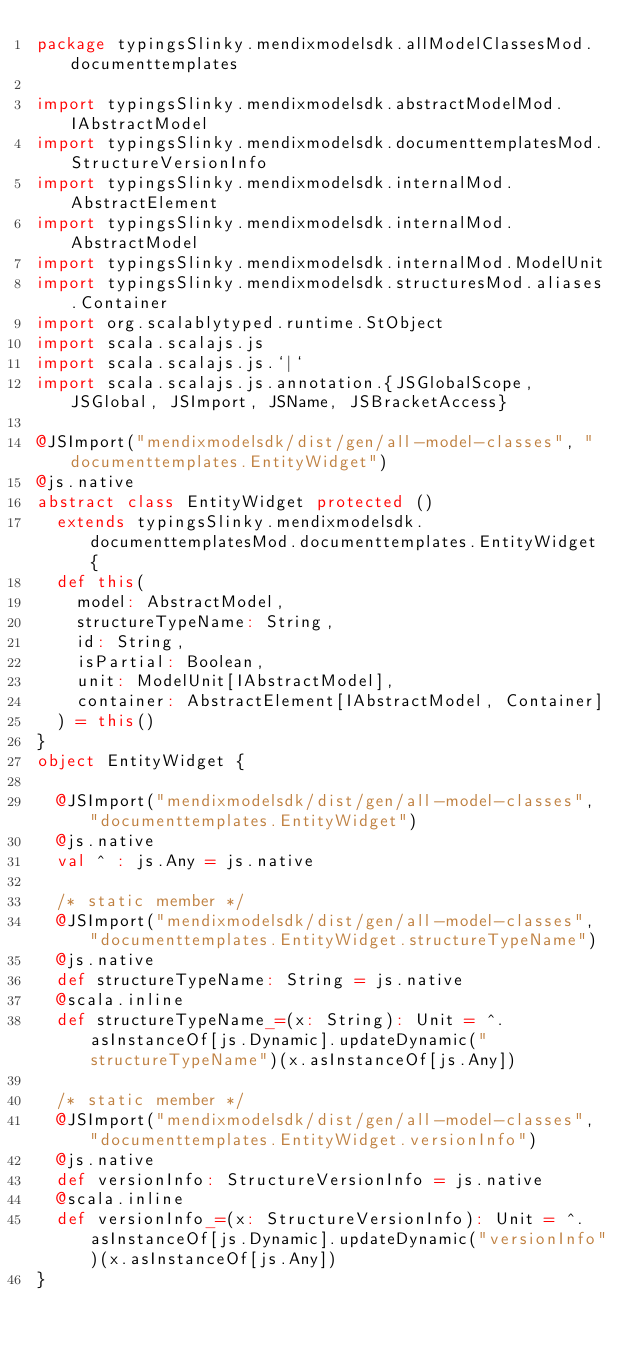Convert code to text. <code><loc_0><loc_0><loc_500><loc_500><_Scala_>package typingsSlinky.mendixmodelsdk.allModelClassesMod.documenttemplates

import typingsSlinky.mendixmodelsdk.abstractModelMod.IAbstractModel
import typingsSlinky.mendixmodelsdk.documenttemplatesMod.StructureVersionInfo
import typingsSlinky.mendixmodelsdk.internalMod.AbstractElement
import typingsSlinky.mendixmodelsdk.internalMod.AbstractModel
import typingsSlinky.mendixmodelsdk.internalMod.ModelUnit
import typingsSlinky.mendixmodelsdk.structuresMod.aliases.Container
import org.scalablytyped.runtime.StObject
import scala.scalajs.js
import scala.scalajs.js.`|`
import scala.scalajs.js.annotation.{JSGlobalScope, JSGlobal, JSImport, JSName, JSBracketAccess}

@JSImport("mendixmodelsdk/dist/gen/all-model-classes", "documenttemplates.EntityWidget")
@js.native
abstract class EntityWidget protected ()
  extends typingsSlinky.mendixmodelsdk.documenttemplatesMod.documenttemplates.EntityWidget {
  def this(
    model: AbstractModel,
    structureTypeName: String,
    id: String,
    isPartial: Boolean,
    unit: ModelUnit[IAbstractModel],
    container: AbstractElement[IAbstractModel, Container]
  ) = this()
}
object EntityWidget {
  
  @JSImport("mendixmodelsdk/dist/gen/all-model-classes", "documenttemplates.EntityWidget")
  @js.native
  val ^ : js.Any = js.native
  
  /* static member */
  @JSImport("mendixmodelsdk/dist/gen/all-model-classes", "documenttemplates.EntityWidget.structureTypeName")
  @js.native
  def structureTypeName: String = js.native
  @scala.inline
  def structureTypeName_=(x: String): Unit = ^.asInstanceOf[js.Dynamic].updateDynamic("structureTypeName")(x.asInstanceOf[js.Any])
  
  /* static member */
  @JSImport("mendixmodelsdk/dist/gen/all-model-classes", "documenttemplates.EntityWidget.versionInfo")
  @js.native
  def versionInfo: StructureVersionInfo = js.native
  @scala.inline
  def versionInfo_=(x: StructureVersionInfo): Unit = ^.asInstanceOf[js.Dynamic].updateDynamic("versionInfo")(x.asInstanceOf[js.Any])
}
</code> 